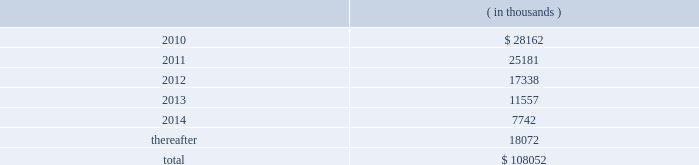There were no changes in the company 2019s valuation techniques used to measure fair values on a recurring basis as a result of adopting asc 820 .
Pca had no assets or liabilities that were measured on a nonrecurring basis .
11 .
Stockholders 2019 equity on october 17 , 2007 , pca announced that its board of directors authorized a $ 150.0 million common stock repurchase program .
There is no expiration date for the common stock repurchase program .
Through december 31 , 2008 , the company repurchased 3818729 shares of common stock , with 3142600 shares repurchased during 2008 and 676129 shares repurchased during 2007 .
All repurchased shares were retired prior to december 31 , 2008 .
There were no shares repurchased in 2009 .
As of december 31 , 2009 , $ 65.0 million of the $ 150.0 million authorization remained available for repurchase of the company 2019s common stock .
12 .
Commitments and contingencies capital commitments the company had authorized capital commitments of approximately $ 41.7 million and $ 43.0 million as of december 31 , 2009 and 2008 , respectively , in connection with the expansion and replacement of existing facilities and equipment .
In addition , commitments at december 31 , 2009 for the major energy optimization projects at its counce and valdosta mills totaled $ 156.3 million .
Lease obligations pca leases space for certain of its facilities and cutting rights to approximately 91000 acres of timberland under long-term leases .
The company also leases equipment , primarily vehicles and rolling stock , and other assets under long-term leases with a duration of two to seven years .
The minimum lease payments under non-cancelable operating leases with lease terms in excess of one year are as follows: .
Total lease expense , including base rent on all leases and executory costs , such as insurance , taxes , and maintenance , for the years ended december 31 , 2009 , 2008 and 2007 was $ 41.3 million , $ 41.6 million and $ 39.8 million , respectively .
These costs are included in cost of goods sold and selling and administrative expenses .
Pca was obligated under capital leases covering buildings and machinery and equipment in the amount of $ 23.1 million and $ 23.7 million at december 31 , 2009 and 2008 , respectively .
During the fourth quarter of 2008 , the company entered into a capital lease relating to buildings and machinery , totaling $ 23.9 million , payable over 20 years .
This capital lease amount is a non-cash transaction and , accordingly , has been excluded packaging corporation of america notes to consolidated financial statements ( continued ) december 31 , 2009 .
Capital leases covering buildings and machinery and equipment in millions totaled what for 2009 and 2008? 
Computations: (23.1 + 23.7)
Answer: 46.8. There were no changes in the company 2019s valuation techniques used to measure fair values on a recurring basis as a result of adopting asc 820 .
Pca had no assets or liabilities that were measured on a nonrecurring basis .
11 .
Stockholders 2019 equity on october 17 , 2007 , pca announced that its board of directors authorized a $ 150.0 million common stock repurchase program .
There is no expiration date for the common stock repurchase program .
Through december 31 , 2008 , the company repurchased 3818729 shares of common stock , with 3142600 shares repurchased during 2008 and 676129 shares repurchased during 2007 .
All repurchased shares were retired prior to december 31 , 2008 .
There were no shares repurchased in 2009 .
As of december 31 , 2009 , $ 65.0 million of the $ 150.0 million authorization remained available for repurchase of the company 2019s common stock .
12 .
Commitments and contingencies capital commitments the company had authorized capital commitments of approximately $ 41.7 million and $ 43.0 million as of december 31 , 2009 and 2008 , respectively , in connection with the expansion and replacement of existing facilities and equipment .
In addition , commitments at december 31 , 2009 for the major energy optimization projects at its counce and valdosta mills totaled $ 156.3 million .
Lease obligations pca leases space for certain of its facilities and cutting rights to approximately 91000 acres of timberland under long-term leases .
The company also leases equipment , primarily vehicles and rolling stock , and other assets under long-term leases with a duration of two to seven years .
The minimum lease payments under non-cancelable operating leases with lease terms in excess of one year are as follows: .
Total lease expense , including base rent on all leases and executory costs , such as insurance , taxes , and maintenance , for the years ended december 31 , 2009 , 2008 and 2007 was $ 41.3 million , $ 41.6 million and $ 39.8 million , respectively .
These costs are included in cost of goods sold and selling and administrative expenses .
Pca was obligated under capital leases covering buildings and machinery and equipment in the amount of $ 23.1 million and $ 23.7 million at december 31 , 2009 and 2008 , respectively .
During the fourth quarter of 2008 , the company entered into a capital lease relating to buildings and machinery , totaling $ 23.9 million , payable over 20 years .
This capital lease amount is a non-cash transaction and , accordingly , has been excluded packaging corporation of america notes to consolidated financial statements ( continued ) december 31 , 2009 .
What percentage of total minimum lease payments under non-cancelable operating leases with lease terms in excess of one year are due in 2012? 
Computations: (17338 / 108052)
Answer: 0.16046. 